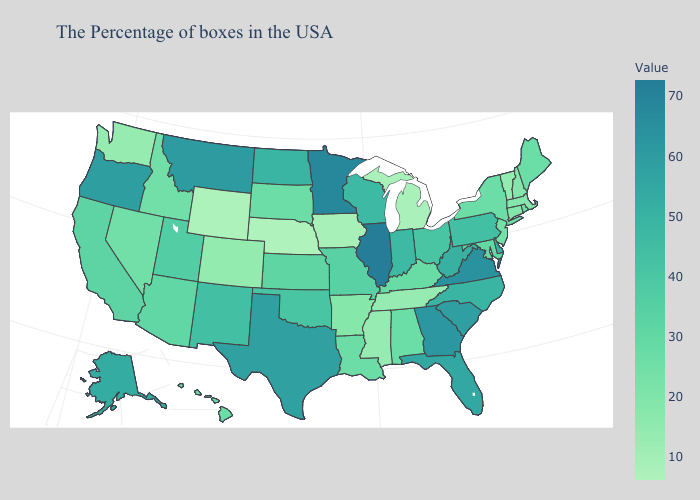Does Georgia have a higher value than Ohio?
Short answer required. Yes. Among the states that border Maryland , does West Virginia have the lowest value?
Write a very short answer. No. Does Wisconsin have the highest value in the MidWest?
Answer briefly. No. Among the states that border Wyoming , does South Dakota have the highest value?
Quick response, please. No. Which states have the highest value in the USA?
Short answer required. Illinois. Does Pennsylvania have the highest value in the Northeast?
Be succinct. Yes. Does Rhode Island have the highest value in the Northeast?
Short answer required. No. 